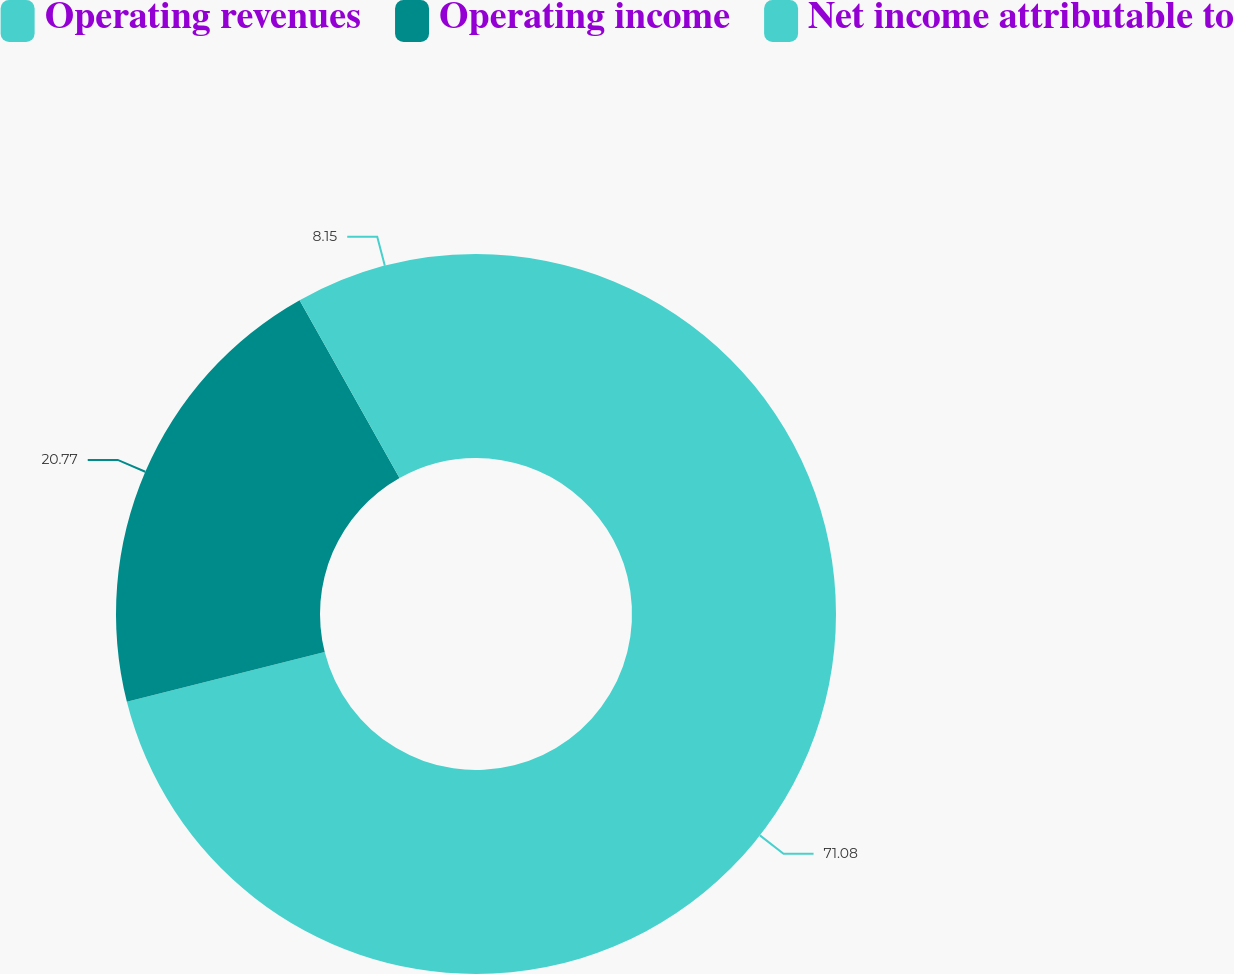Convert chart. <chart><loc_0><loc_0><loc_500><loc_500><pie_chart><fcel>Operating revenues<fcel>Operating income<fcel>Net income attributable to<nl><fcel>71.08%<fcel>20.77%<fcel>8.15%<nl></chart> 